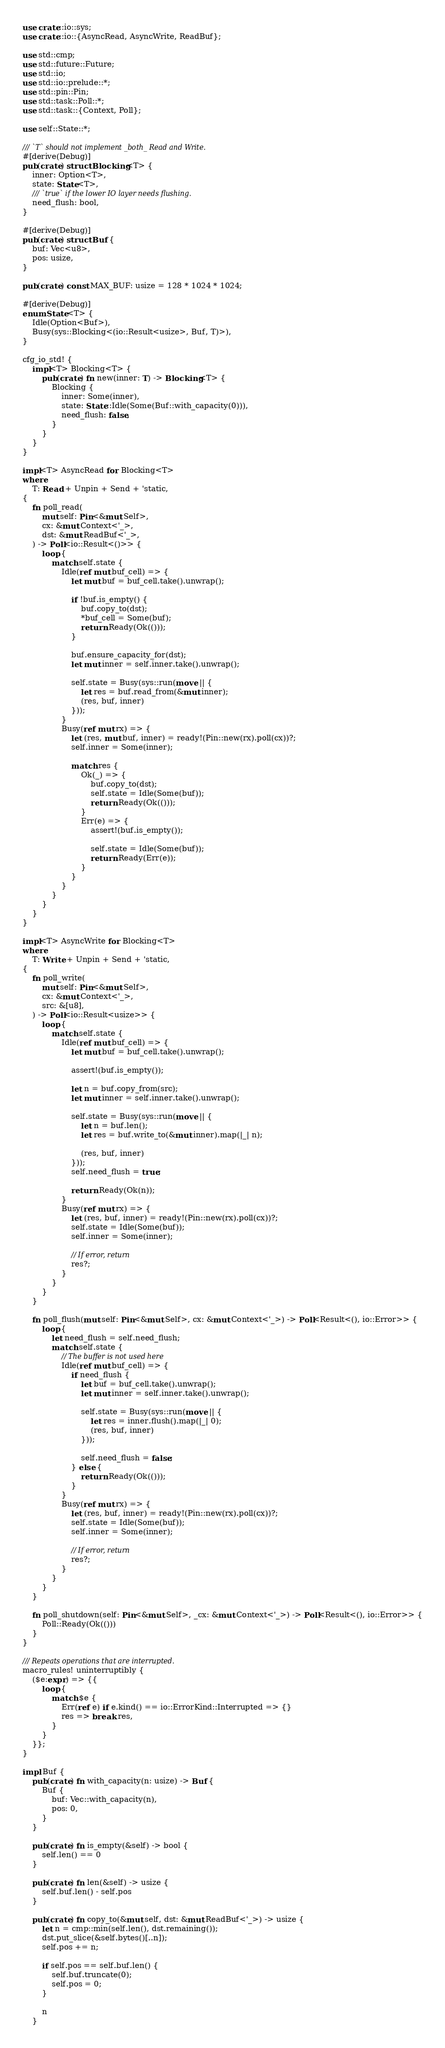Convert code to text. <code><loc_0><loc_0><loc_500><loc_500><_Rust_>use crate::io::sys;
use crate::io::{AsyncRead, AsyncWrite, ReadBuf};

use std::cmp;
use std::future::Future;
use std::io;
use std::io::prelude::*;
use std::pin::Pin;
use std::task::Poll::*;
use std::task::{Context, Poll};

use self::State::*;

/// `T` should not implement _both_ Read and Write.
#[derive(Debug)]
pub(crate) struct Blocking<T> {
    inner: Option<T>,
    state: State<T>,
    /// `true` if the lower IO layer needs flushing.
    need_flush: bool,
}

#[derive(Debug)]
pub(crate) struct Buf {
    buf: Vec<u8>,
    pos: usize,
}

pub(crate) const MAX_BUF: usize = 128 * 1024 * 1024;

#[derive(Debug)]
enum State<T> {
    Idle(Option<Buf>),
    Busy(sys::Blocking<(io::Result<usize>, Buf, T)>),
}

cfg_io_std! {
    impl<T> Blocking<T> {
        pub(crate) fn new(inner: T) -> Blocking<T> {
            Blocking {
                inner: Some(inner),
                state: State::Idle(Some(Buf::with_capacity(0))),
                need_flush: false,
            }
        }
    }
}

impl<T> AsyncRead for Blocking<T>
where
    T: Read + Unpin + Send + 'static,
{
    fn poll_read(
        mut self: Pin<&mut Self>,
        cx: &mut Context<'_>,
        dst: &mut ReadBuf<'_>,
    ) -> Poll<io::Result<()>> {
        loop {
            match self.state {
                Idle(ref mut buf_cell) => {
                    let mut buf = buf_cell.take().unwrap();

                    if !buf.is_empty() {
                        buf.copy_to(dst);
                        *buf_cell = Some(buf);
                        return Ready(Ok(()));
                    }

                    buf.ensure_capacity_for(dst);
                    let mut inner = self.inner.take().unwrap();

                    self.state = Busy(sys::run(move || {
                        let res = buf.read_from(&mut inner);
                        (res, buf, inner)
                    }));
                }
                Busy(ref mut rx) => {
                    let (res, mut buf, inner) = ready!(Pin::new(rx).poll(cx))?;
                    self.inner = Some(inner);

                    match res {
                        Ok(_) => {
                            buf.copy_to(dst);
                            self.state = Idle(Some(buf));
                            return Ready(Ok(()));
                        }
                        Err(e) => {
                            assert!(buf.is_empty());

                            self.state = Idle(Some(buf));
                            return Ready(Err(e));
                        }
                    }
                }
            }
        }
    }
}

impl<T> AsyncWrite for Blocking<T>
where
    T: Write + Unpin + Send + 'static,
{
    fn poll_write(
        mut self: Pin<&mut Self>,
        cx: &mut Context<'_>,
        src: &[u8],
    ) -> Poll<io::Result<usize>> {
        loop {
            match self.state {
                Idle(ref mut buf_cell) => {
                    let mut buf = buf_cell.take().unwrap();

                    assert!(buf.is_empty());

                    let n = buf.copy_from(src);
                    let mut inner = self.inner.take().unwrap();

                    self.state = Busy(sys::run(move || {
                        let n = buf.len();
                        let res = buf.write_to(&mut inner).map(|_| n);

                        (res, buf, inner)
                    }));
                    self.need_flush = true;

                    return Ready(Ok(n));
                }
                Busy(ref mut rx) => {
                    let (res, buf, inner) = ready!(Pin::new(rx).poll(cx))?;
                    self.state = Idle(Some(buf));
                    self.inner = Some(inner);

                    // If error, return
                    res?;
                }
            }
        }
    }

    fn poll_flush(mut self: Pin<&mut Self>, cx: &mut Context<'_>) -> Poll<Result<(), io::Error>> {
        loop {
            let need_flush = self.need_flush;
            match self.state {
                // The buffer is not used here
                Idle(ref mut buf_cell) => {
                    if need_flush {
                        let buf = buf_cell.take().unwrap();
                        let mut inner = self.inner.take().unwrap();

                        self.state = Busy(sys::run(move || {
                            let res = inner.flush().map(|_| 0);
                            (res, buf, inner)
                        }));

                        self.need_flush = false;
                    } else {
                        return Ready(Ok(()));
                    }
                }
                Busy(ref mut rx) => {
                    let (res, buf, inner) = ready!(Pin::new(rx).poll(cx))?;
                    self.state = Idle(Some(buf));
                    self.inner = Some(inner);

                    // If error, return
                    res?;
                }
            }
        }
    }

    fn poll_shutdown(self: Pin<&mut Self>, _cx: &mut Context<'_>) -> Poll<Result<(), io::Error>> {
        Poll::Ready(Ok(()))
    }
}

/// Repeats operations that are interrupted.
macro_rules! uninterruptibly {
    ($e:expr) => {{
        loop {
            match $e {
                Err(ref e) if e.kind() == io::ErrorKind::Interrupted => {}
                res => break res,
            }
        }
    }};
}

impl Buf {
    pub(crate) fn with_capacity(n: usize) -> Buf {
        Buf {
            buf: Vec::with_capacity(n),
            pos: 0,
        }
    }

    pub(crate) fn is_empty(&self) -> bool {
        self.len() == 0
    }

    pub(crate) fn len(&self) -> usize {
        self.buf.len() - self.pos
    }

    pub(crate) fn copy_to(&mut self, dst: &mut ReadBuf<'_>) -> usize {
        let n = cmp::min(self.len(), dst.remaining());
        dst.put_slice(&self.bytes()[..n]);
        self.pos += n;

        if self.pos == self.buf.len() {
            self.buf.truncate(0);
            self.pos = 0;
        }

        n
    }
</code> 